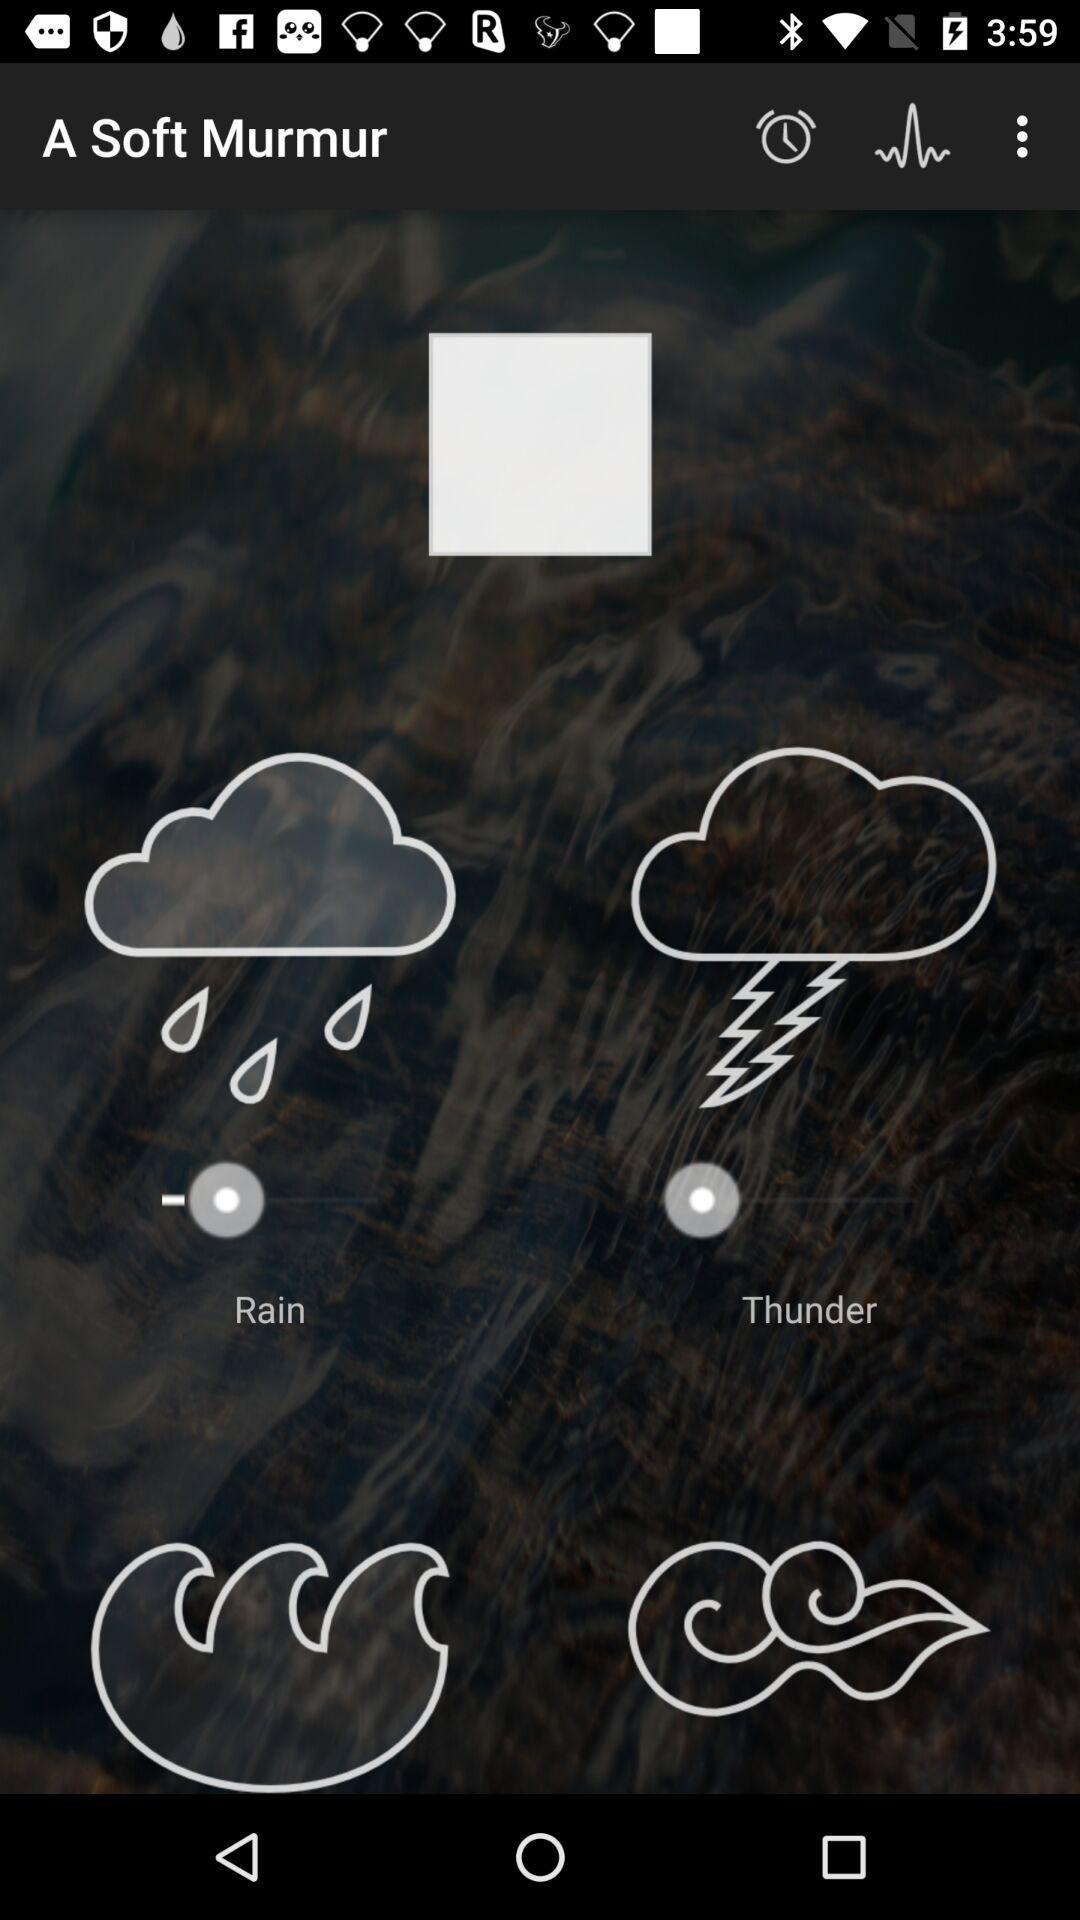What is the application name? The application name is "A Soft Murmur". 